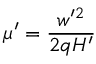<formula> <loc_0><loc_0><loc_500><loc_500>\mu ^ { \prime } = \frac { w ^ { \prime 2 } } { 2 q H ^ { \prime } }</formula> 